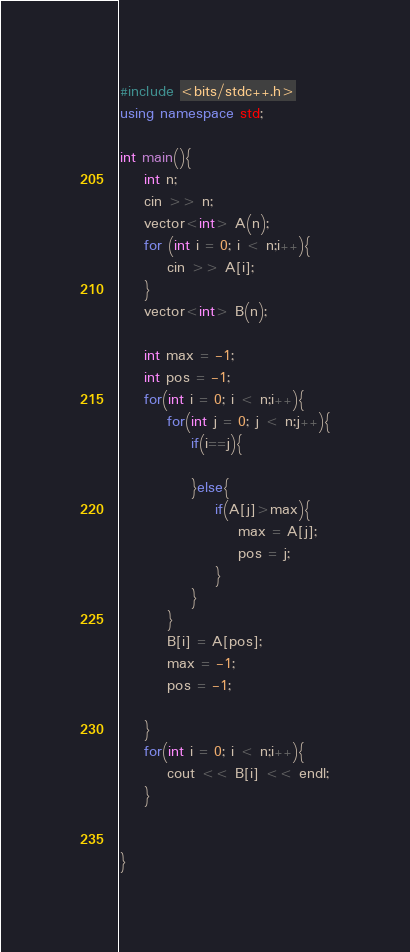<code> <loc_0><loc_0><loc_500><loc_500><_C++_>#include <bits/stdc++.h>
using namespace std;
 
int main(){
    int n;
    cin >> n;
    vector<int> A(n);
    for (int i = 0; i < n;i++){
        cin >> A[i];
    }
    vector<int> B(n);

    int max = -1;
    int pos = -1;
    for(int i = 0; i < n;i++){
        for(int j = 0; j < n;j++){
            if(i==j){

            }else{
                if(A[j]>max){
                    max = A[j];
                    pos = j;
                }
            }
        }
        B[i] = A[pos];
        max = -1;
        pos = -1;

    }
    for(int i = 0; i < n;i++){
        cout << B[i] << endl;
    }

 
}</code> 